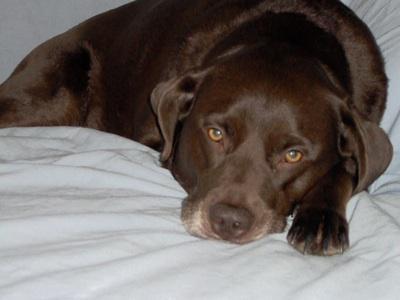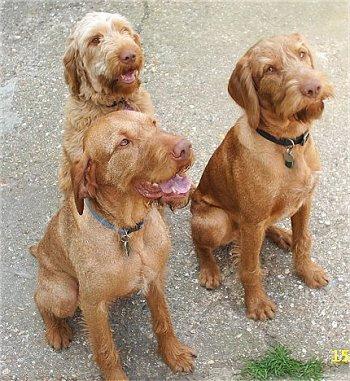The first image is the image on the left, the second image is the image on the right. For the images shown, is this caption "Each image contains a single dog, and each dog pictured is facing forward with its head upright and both eyes visible." true? Answer yes or no. No. The first image is the image on the left, the second image is the image on the right. Evaluate the accuracy of this statement regarding the images: "There are two dogs looking forward at the camera". Is it true? Answer yes or no. No. 